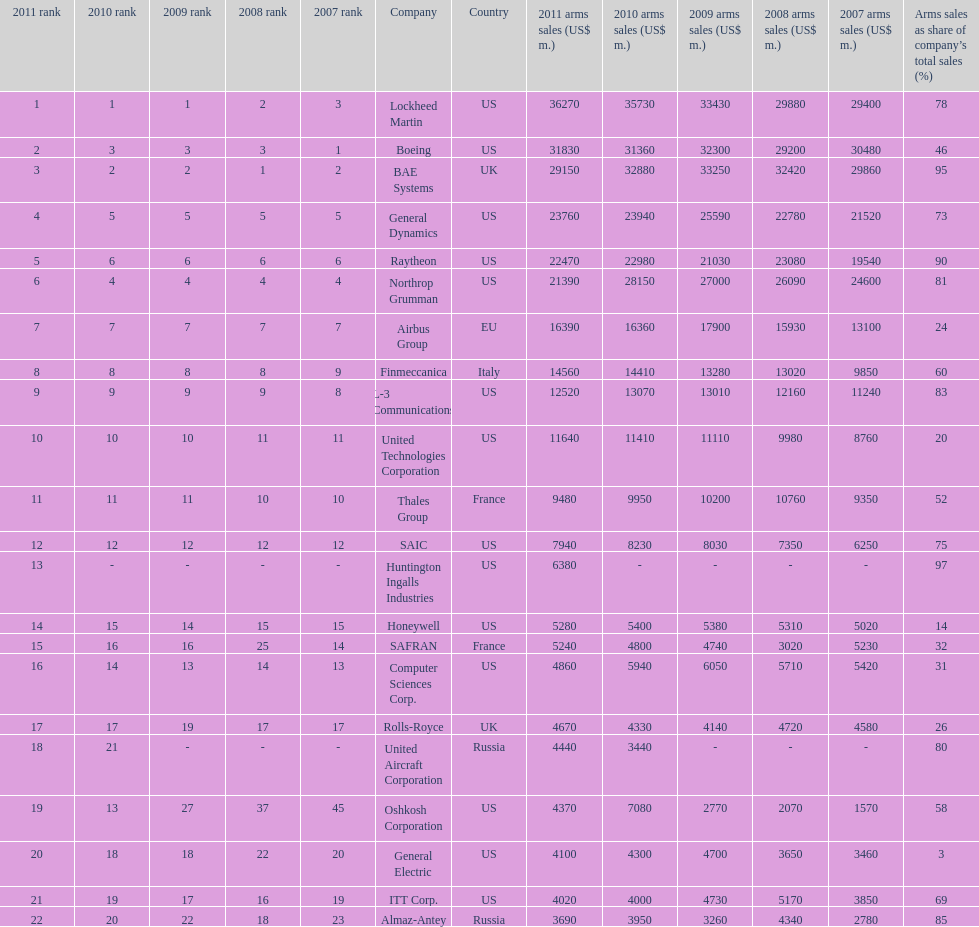Name all the companies whose arms sales as share of company's total sales is below 75%. Boeing, General Dynamics, Airbus Group, Finmeccanica, United Technologies Corporation, Thales Group, Honeywell, SAFRAN, Computer Sciences Corp., Rolls-Royce, Oshkosh Corporation, General Electric, ITT Corp. 